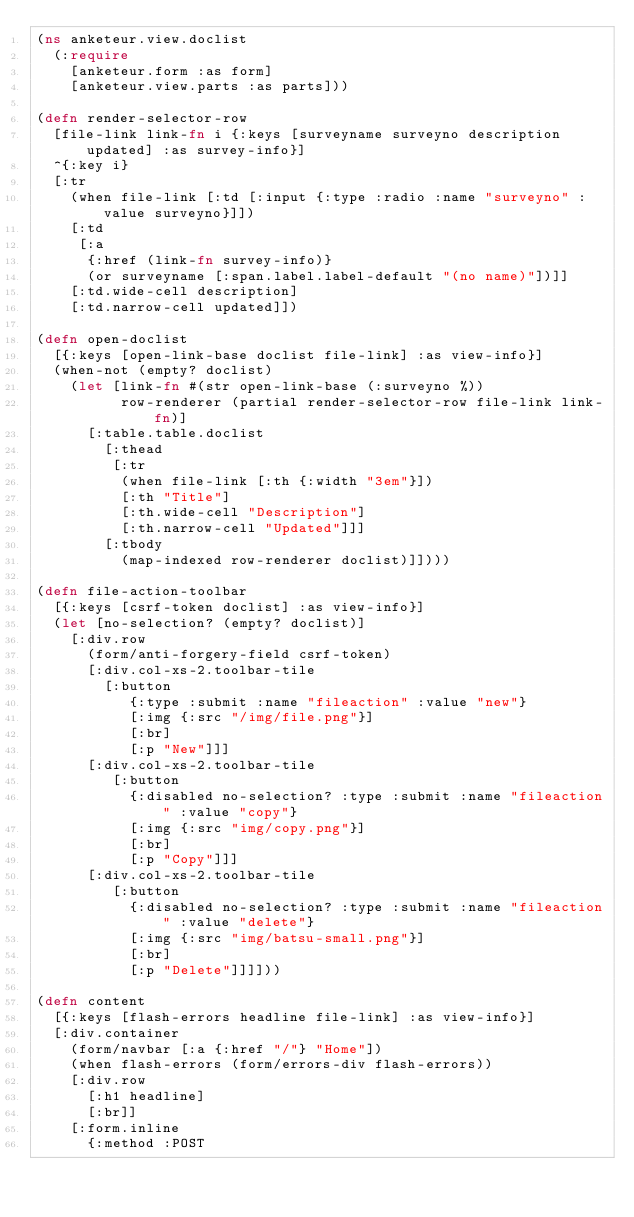Convert code to text. <code><loc_0><loc_0><loc_500><loc_500><_Clojure_>(ns anketeur.view.doclist
  (:require
    [anketeur.form :as form]
    [anketeur.view.parts :as parts]))

(defn render-selector-row
  [file-link link-fn i {:keys [surveyname surveyno description updated] :as survey-info}]
  ^{:key i}
  [:tr
    (when file-link [:td [:input {:type :radio :name "surveyno" :value surveyno}]])
    [:td
     [:a
      {:href (link-fn survey-info)}
      (or surveyname [:span.label.label-default "(no name)"])]]
    [:td.wide-cell description]
    [:td.narrow-cell updated]])

(defn open-doclist
  [{:keys [open-link-base doclist file-link] :as view-info}]
  (when-not (empty? doclist)
    (let [link-fn #(str open-link-base (:surveyno %))
          row-renderer (partial render-selector-row file-link link-fn)]
      [:table.table.doclist
        [:thead
         [:tr
          (when file-link [:th {:width "3em"}])
          [:th "Title"]
          [:th.wide-cell "Description"]
          [:th.narrow-cell "Updated"]]]
        [:tbody
          (map-indexed row-renderer doclist)]])))

(defn file-action-toolbar
  [{:keys [csrf-token doclist] :as view-info}]
  (let [no-selection? (empty? doclist)]
    [:div.row
      (form/anti-forgery-field csrf-token)
      [:div.col-xs-2.toolbar-tile
        [:button
           {:type :submit :name "fileaction" :value "new"}
           [:img {:src "/img/file.png"}]
           [:br]
           [:p "New"]]]
      [:div.col-xs-2.toolbar-tile
         [:button
           {:disabled no-selection? :type :submit :name "fileaction" :value "copy"}
           [:img {:src "img/copy.png"}]
           [:br]
           [:p "Copy"]]]
      [:div.col-xs-2.toolbar-tile
         [:button
           {:disabled no-selection? :type :submit :name "fileaction" :value "delete"}
           [:img {:src "img/batsu-small.png"}]
           [:br]
           [:p "Delete"]]]]))

(defn content
  [{:keys [flash-errors headline file-link] :as view-info}]
  [:div.container
    (form/navbar [:a {:href "/"} "Home"])
    (when flash-errors (form/errors-div flash-errors))
    [:div.row
      [:h1 headline]
      [:br]]
    [:form.inline
      {:method :POST</code> 